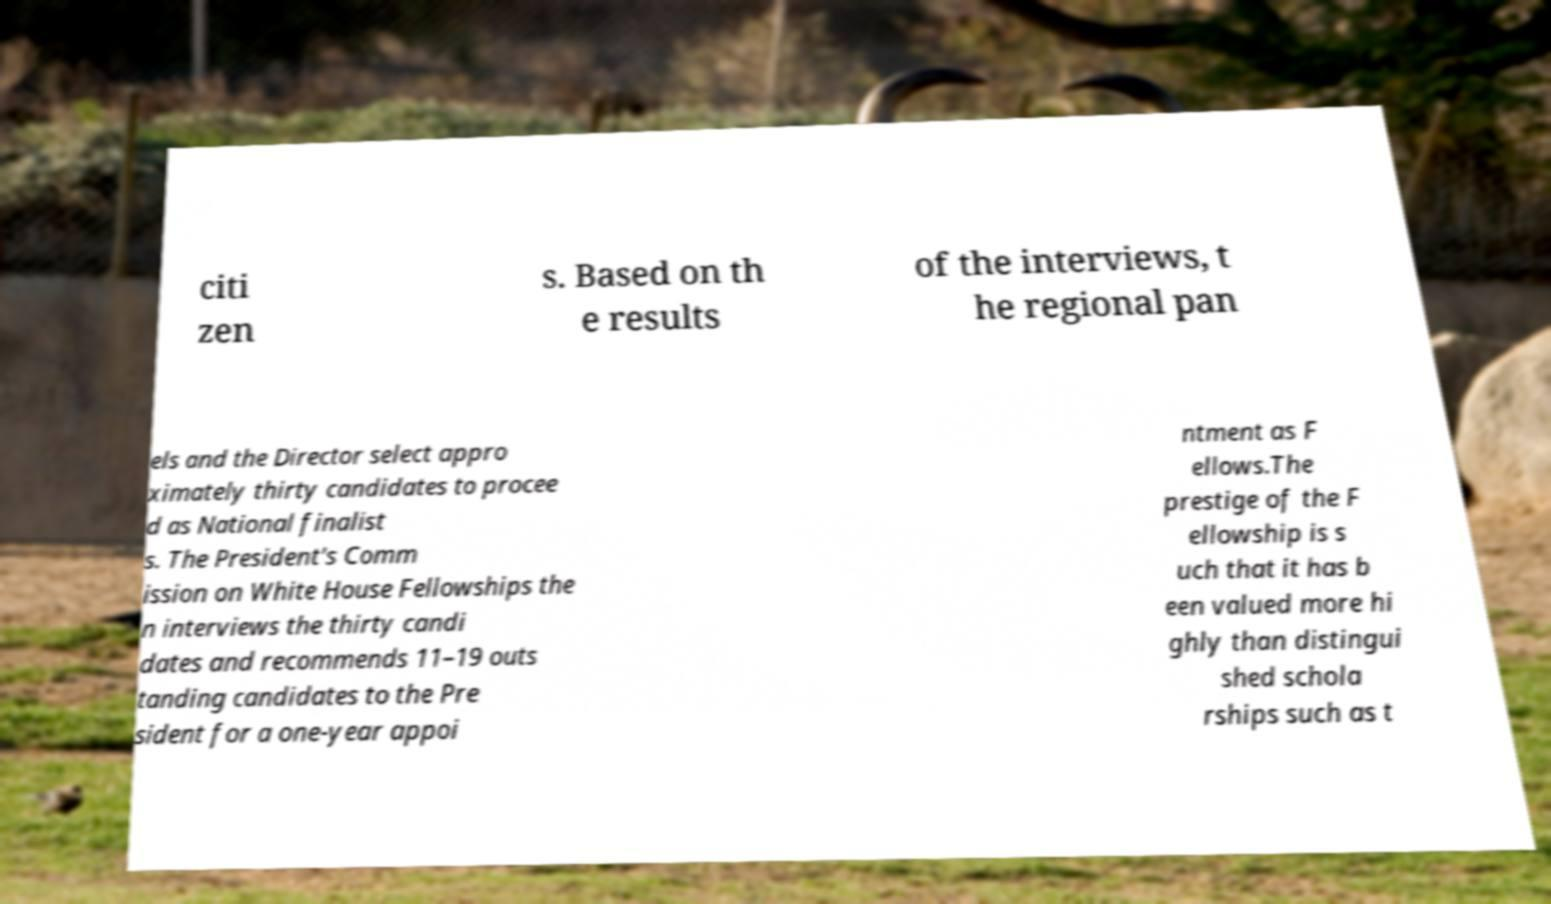What messages or text are displayed in this image? I need them in a readable, typed format. citi zen s. Based on th e results of the interviews, t he regional pan els and the Director select appro ximately thirty candidates to procee d as National finalist s. The President's Comm ission on White House Fellowships the n interviews the thirty candi dates and recommends 11–19 outs tanding candidates to the Pre sident for a one-year appoi ntment as F ellows.The prestige of the F ellowship is s uch that it has b een valued more hi ghly than distingui shed schola rships such as t 